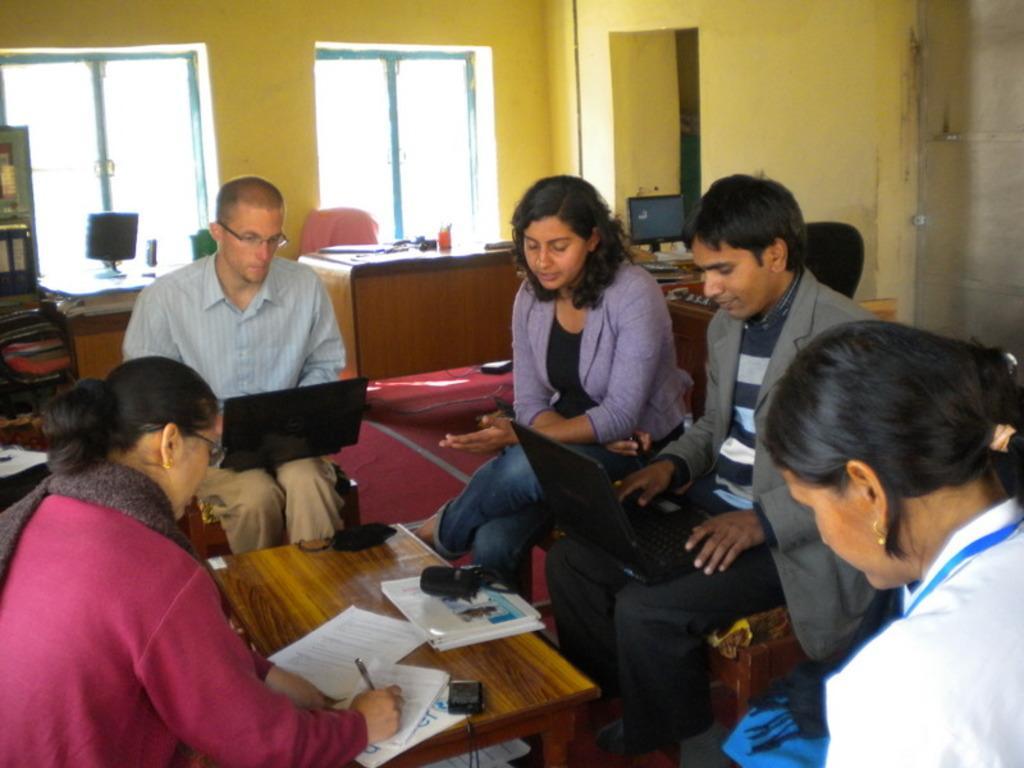Please provide a concise description of this image. In this image there are group of persons sitting in the chair and in table there are pen , paper and in back ground there is table , chair ,computer , rack , window. 